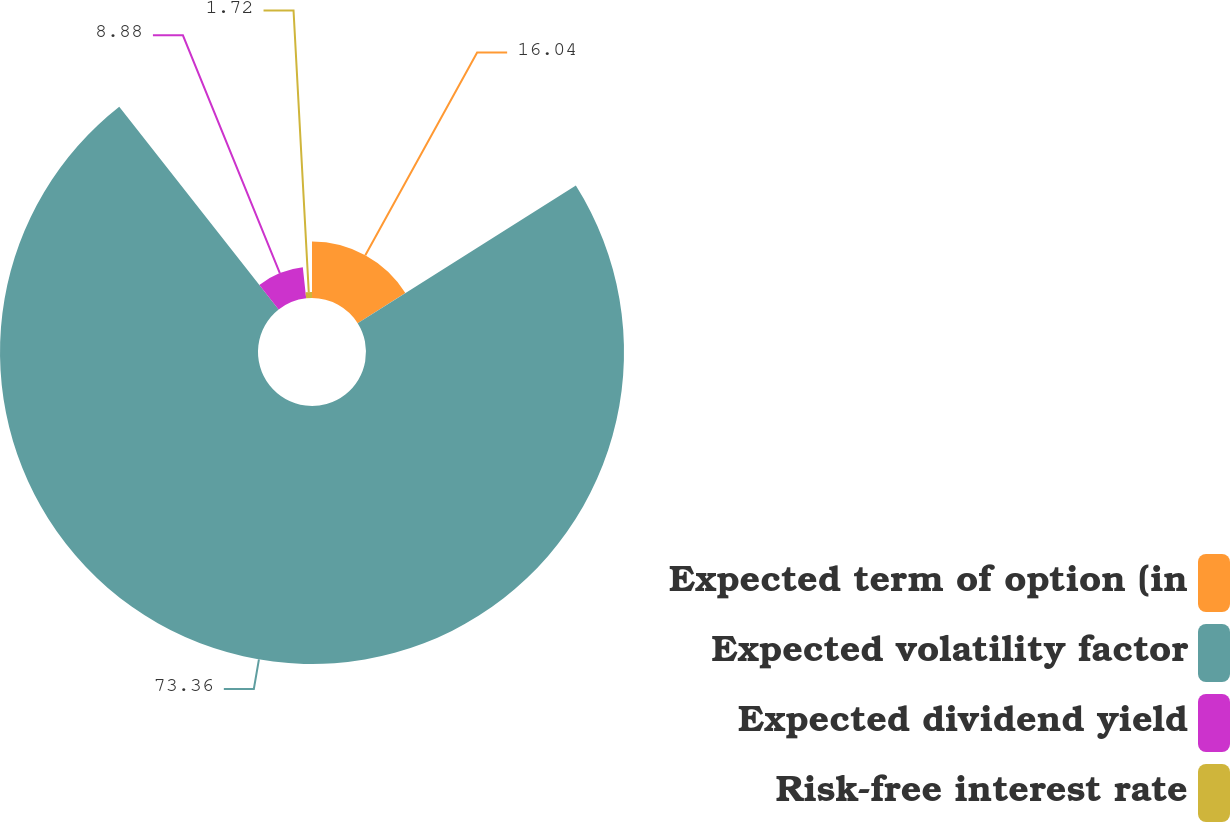Convert chart. <chart><loc_0><loc_0><loc_500><loc_500><pie_chart><fcel>Expected term of option (in<fcel>Expected volatility factor<fcel>Expected dividend yield<fcel>Risk-free interest rate<nl><fcel>16.04%<fcel>73.36%<fcel>8.88%<fcel>1.72%<nl></chart> 